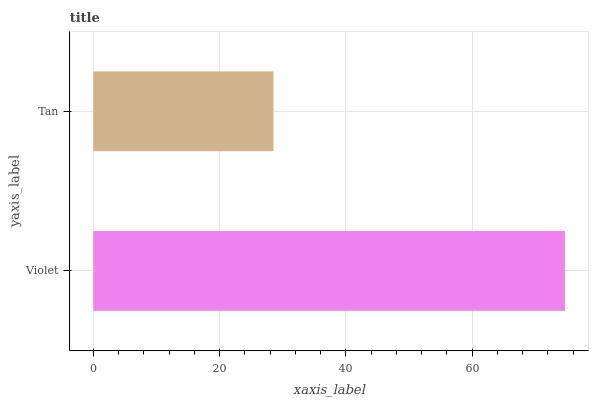Is Tan the minimum?
Answer yes or no. Yes. Is Violet the maximum?
Answer yes or no. Yes. Is Tan the maximum?
Answer yes or no. No. Is Violet greater than Tan?
Answer yes or no. Yes. Is Tan less than Violet?
Answer yes or no. Yes. Is Tan greater than Violet?
Answer yes or no. No. Is Violet less than Tan?
Answer yes or no. No. Is Violet the high median?
Answer yes or no. Yes. Is Tan the low median?
Answer yes or no. Yes. Is Tan the high median?
Answer yes or no. No. Is Violet the low median?
Answer yes or no. No. 